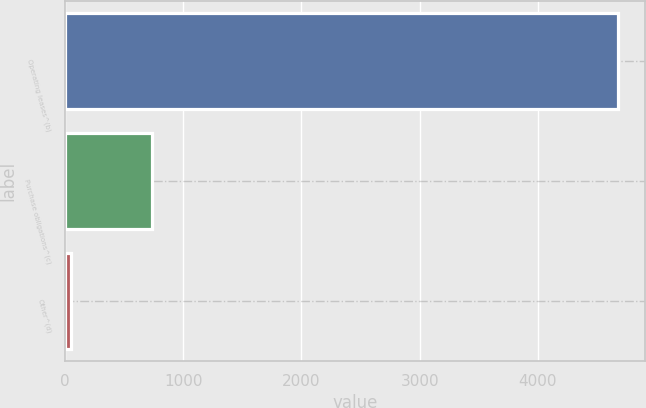<chart> <loc_0><loc_0><loc_500><loc_500><bar_chart><fcel>Operating leases^(b)<fcel>Purchase obligations^(c)<fcel>Other^(d)<nl><fcel>4675<fcel>737<fcel>50<nl></chart> 